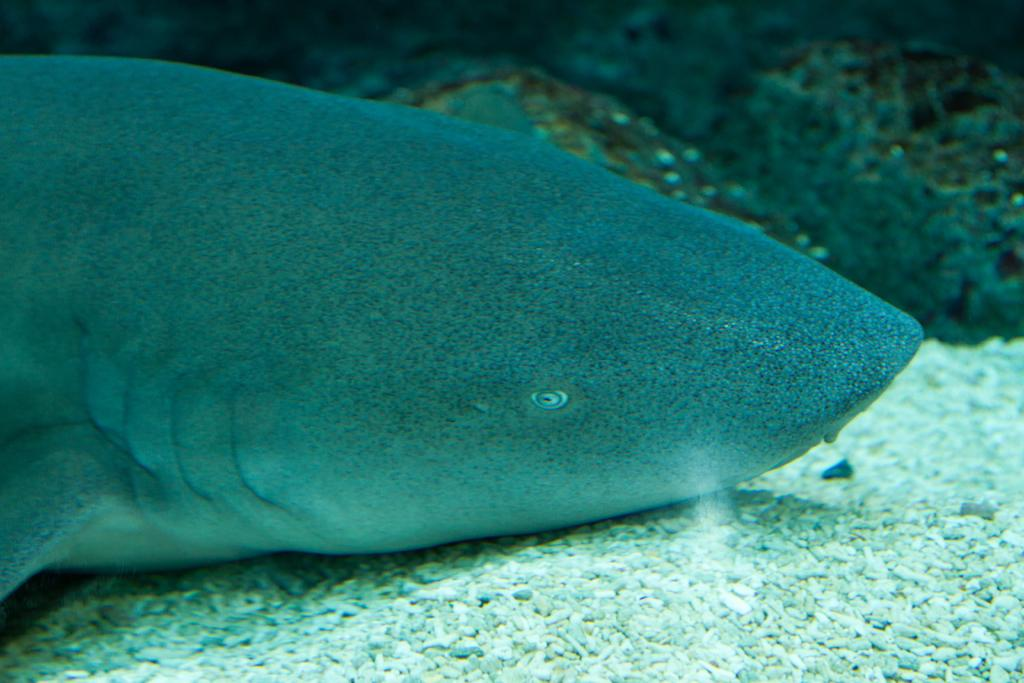What type of animal is in the image? There is a fish in the image. What is the primary element surrounding the fish? There is water visible in the image. What type of material can be seen in the image besides water? There are white stones in the image. What type of road can be seen in the image? There is no road present in the image; it features a fish in water with white stones. What color is the copper in the image? There is no copper present in the image. 